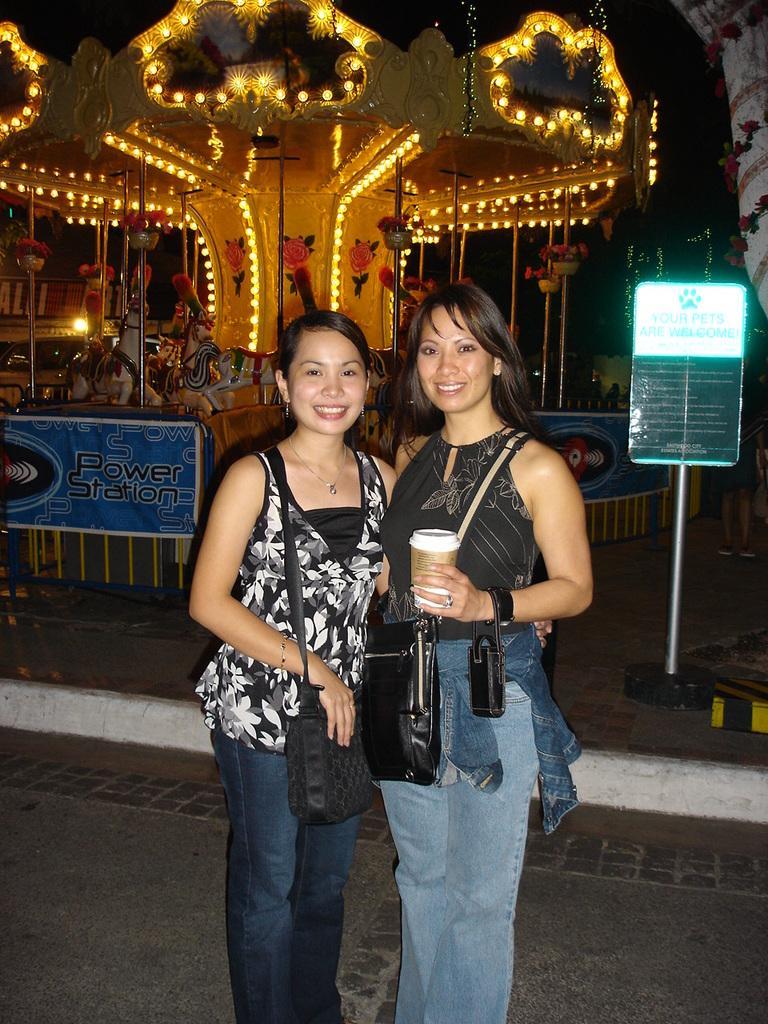In one or two sentences, can you explain what this image depicts? In the picture I can see two women are standing and smiling. The woman is holding a glass in the hand. In the background I can see a board, fence, lights and some other objects on the ground. 